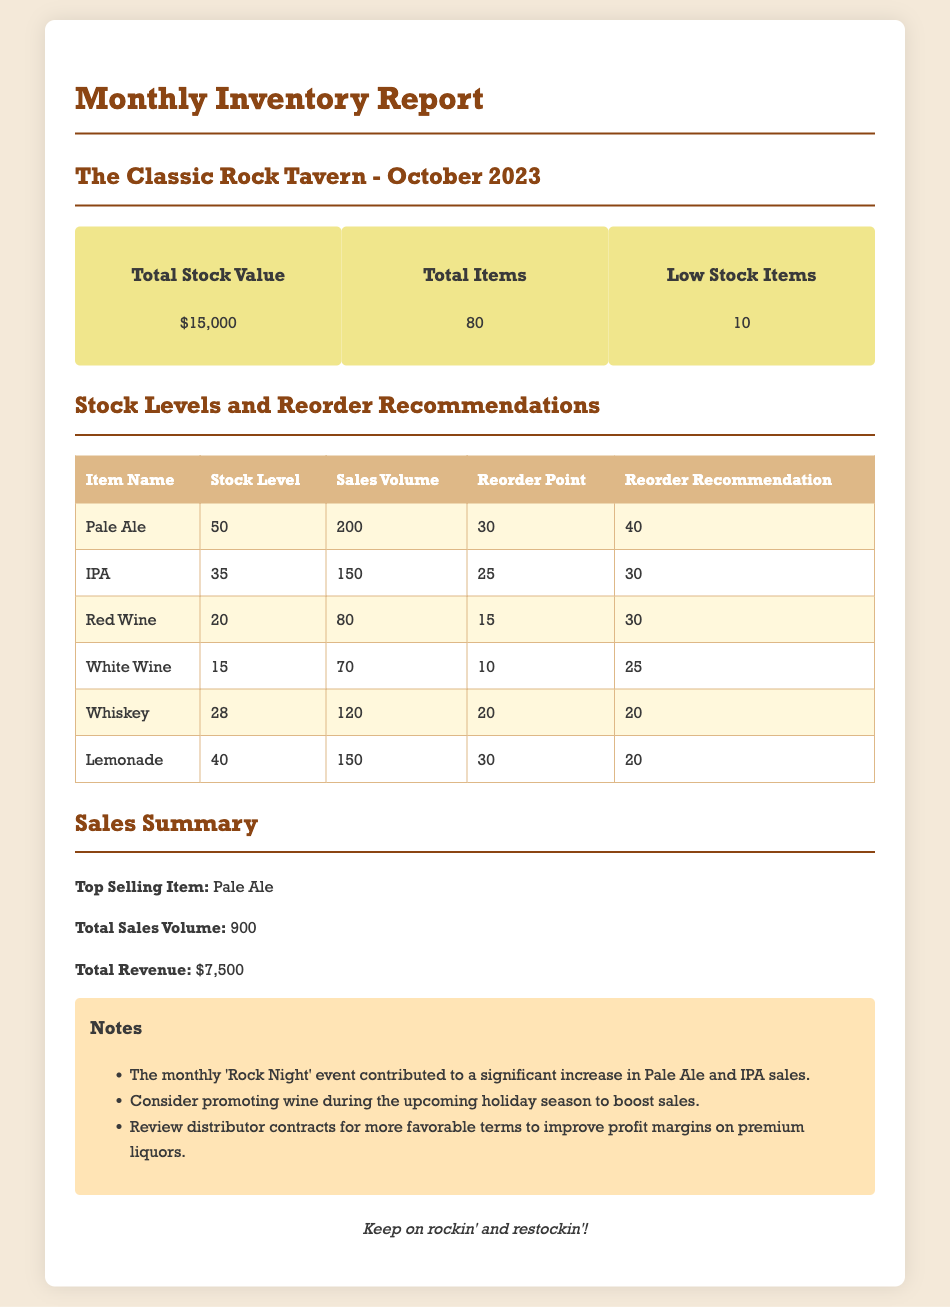What is the total stock value? The total stock value is provided in the summary section of the document.
Answer: $15,000 How many total items are there? The total number of items is mentioned in the summary section of the report.
Answer: 80 What is the low stock item count? The summary section mentions the number of low stock items.
Answer: 10 What is the stock level for Red Wine? The stock level for Red Wine is listed in the table under stock levels.
Answer: 20 What is the sales volume of the top-selling item? The sales volume of the top-selling item, Pale Ale, is indicated in the sales summary.
Answer: 200 Which item has a reorder point of 10? The item with the reorder point of 10 is specified in the stock levels table.
Answer: White Wine What does the note suggest about wine? The notes suggest a promotional strategy related to wine sales.
Answer: Promote during the holiday season What is the total revenue from sales? The total revenue figure is provided in the sales summary section.
Answer: $7,500 Which beverage had increased sales due to 'Rock Night'? The note indicates the items with increased sales during the event.
Answer: Pale Ale and IPA 